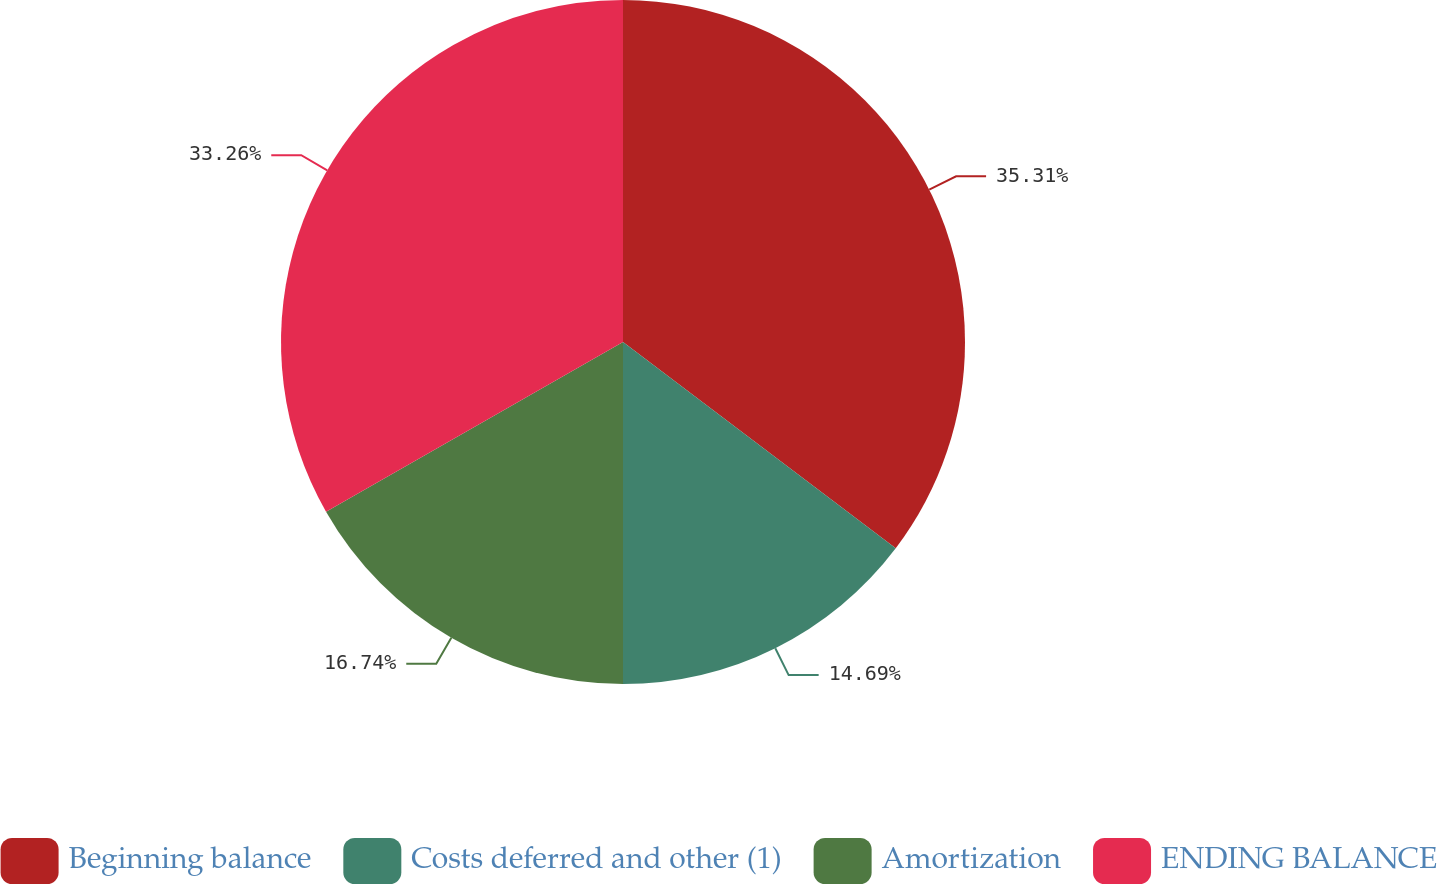<chart> <loc_0><loc_0><loc_500><loc_500><pie_chart><fcel>Beginning balance<fcel>Costs deferred and other (1)<fcel>Amortization<fcel>ENDING BALANCE<nl><fcel>35.31%<fcel>14.69%<fcel>16.74%<fcel>33.26%<nl></chart> 